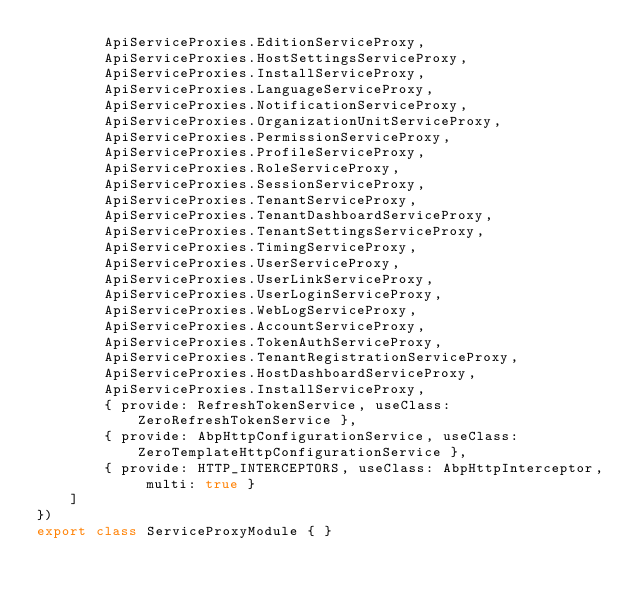Convert code to text. <code><loc_0><loc_0><loc_500><loc_500><_TypeScript_>        ApiServiceProxies.EditionServiceProxy,
        ApiServiceProxies.HostSettingsServiceProxy,
        ApiServiceProxies.InstallServiceProxy,
        ApiServiceProxies.LanguageServiceProxy,
        ApiServiceProxies.NotificationServiceProxy,
        ApiServiceProxies.OrganizationUnitServiceProxy,
        ApiServiceProxies.PermissionServiceProxy,
        ApiServiceProxies.ProfileServiceProxy,
        ApiServiceProxies.RoleServiceProxy,
        ApiServiceProxies.SessionServiceProxy,
        ApiServiceProxies.TenantServiceProxy,
        ApiServiceProxies.TenantDashboardServiceProxy,
        ApiServiceProxies.TenantSettingsServiceProxy,
        ApiServiceProxies.TimingServiceProxy,
        ApiServiceProxies.UserServiceProxy,
        ApiServiceProxies.UserLinkServiceProxy,
        ApiServiceProxies.UserLoginServiceProxy,
        ApiServiceProxies.WebLogServiceProxy,
        ApiServiceProxies.AccountServiceProxy,
        ApiServiceProxies.TokenAuthServiceProxy,
        ApiServiceProxies.TenantRegistrationServiceProxy,
        ApiServiceProxies.HostDashboardServiceProxy,
        ApiServiceProxies.InstallServiceProxy,
        { provide: RefreshTokenService, useClass: ZeroRefreshTokenService },
        { provide: AbpHttpConfigurationService, useClass: ZeroTemplateHttpConfigurationService },
        { provide: HTTP_INTERCEPTORS, useClass: AbpHttpInterceptor, multi: true }
    ]
})
export class ServiceProxyModule { }
</code> 